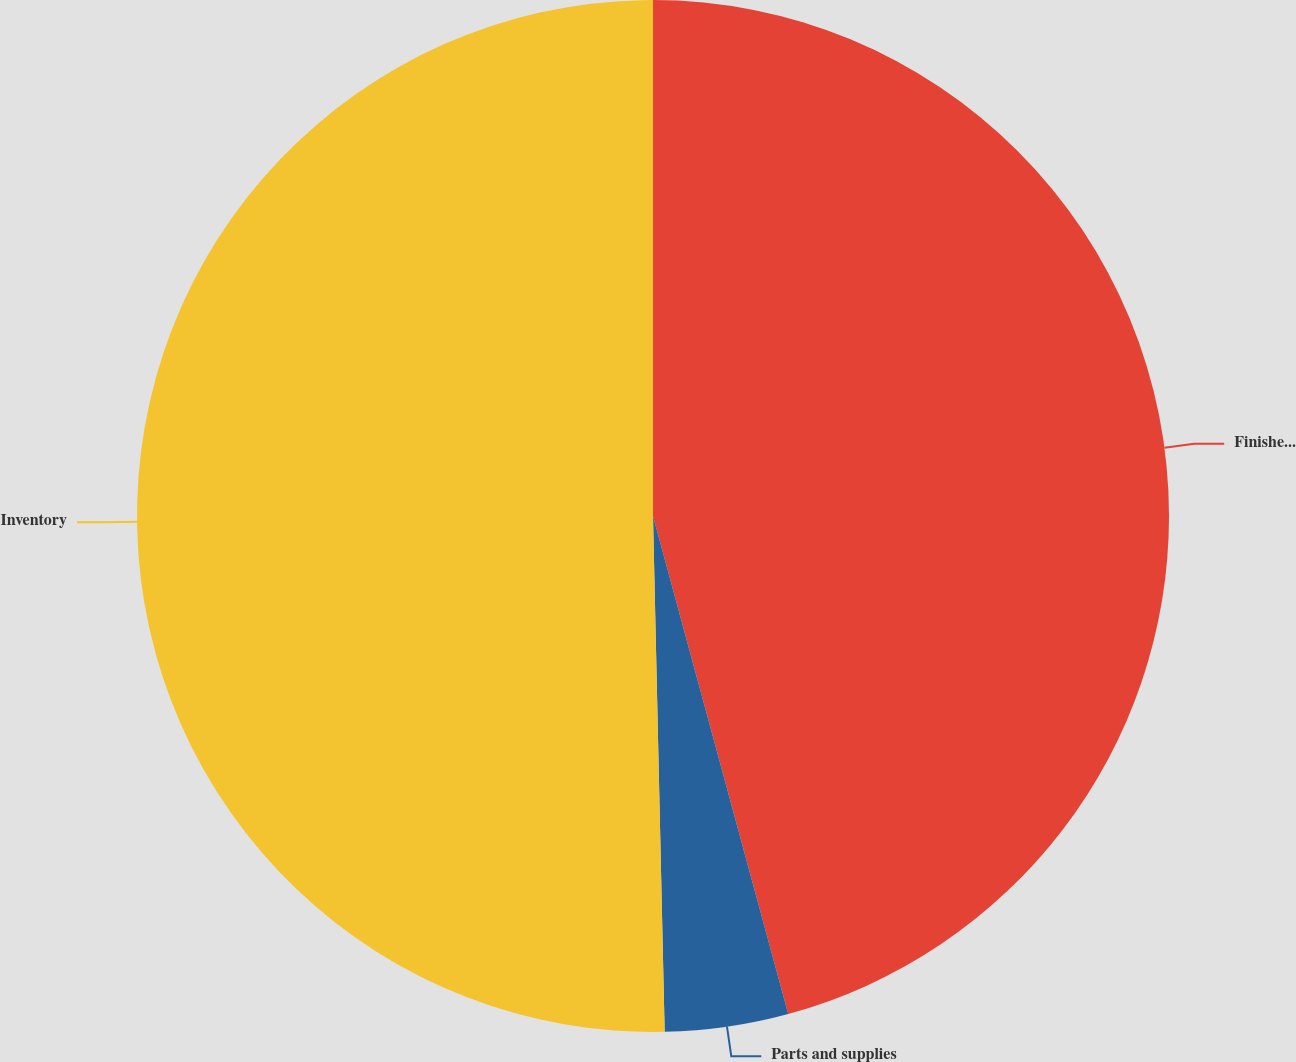Convert chart. <chart><loc_0><loc_0><loc_500><loc_500><pie_chart><fcel>Finished products<fcel>Parts and supplies<fcel>Inventory<nl><fcel>45.78%<fcel>3.86%<fcel>50.36%<nl></chart> 